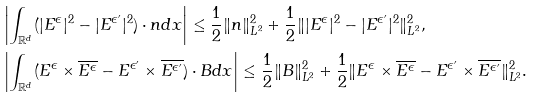Convert formula to latex. <formula><loc_0><loc_0><loc_500><loc_500>& \left | \int _ { \mathbb { R } ^ { d } } ( | E ^ { \epsilon } | ^ { 2 } - | E ^ { \epsilon ^ { \prime } } | ^ { 2 } ) \cdot n d x \right | \leq \frac { 1 } { 2 } \| n \| _ { L ^ { 2 } } ^ { 2 } + \frac { 1 } { 2 } \| | E ^ { \epsilon } | ^ { 2 } - | E ^ { \epsilon ^ { \prime } } | ^ { 2 } \| _ { L ^ { 2 } } ^ { 2 } , \\ & \left | \int _ { \mathbb { R } ^ { d } } ( E ^ { \epsilon } \times \overline { E ^ { \epsilon } } - E ^ { \epsilon ^ { \prime } } \times \overline { E ^ { \epsilon ^ { \prime } } } ) \cdot B d x \right | \leq \frac { 1 } { 2 } \| B \| _ { L ^ { 2 } } ^ { 2 } + \frac { 1 } { 2 } \| E ^ { \epsilon } \times \overline { E ^ { \epsilon } } - E ^ { \epsilon ^ { \prime } } \times \overline { E ^ { \epsilon ^ { \prime } } } \| _ { L ^ { 2 } } ^ { 2 } .</formula> 